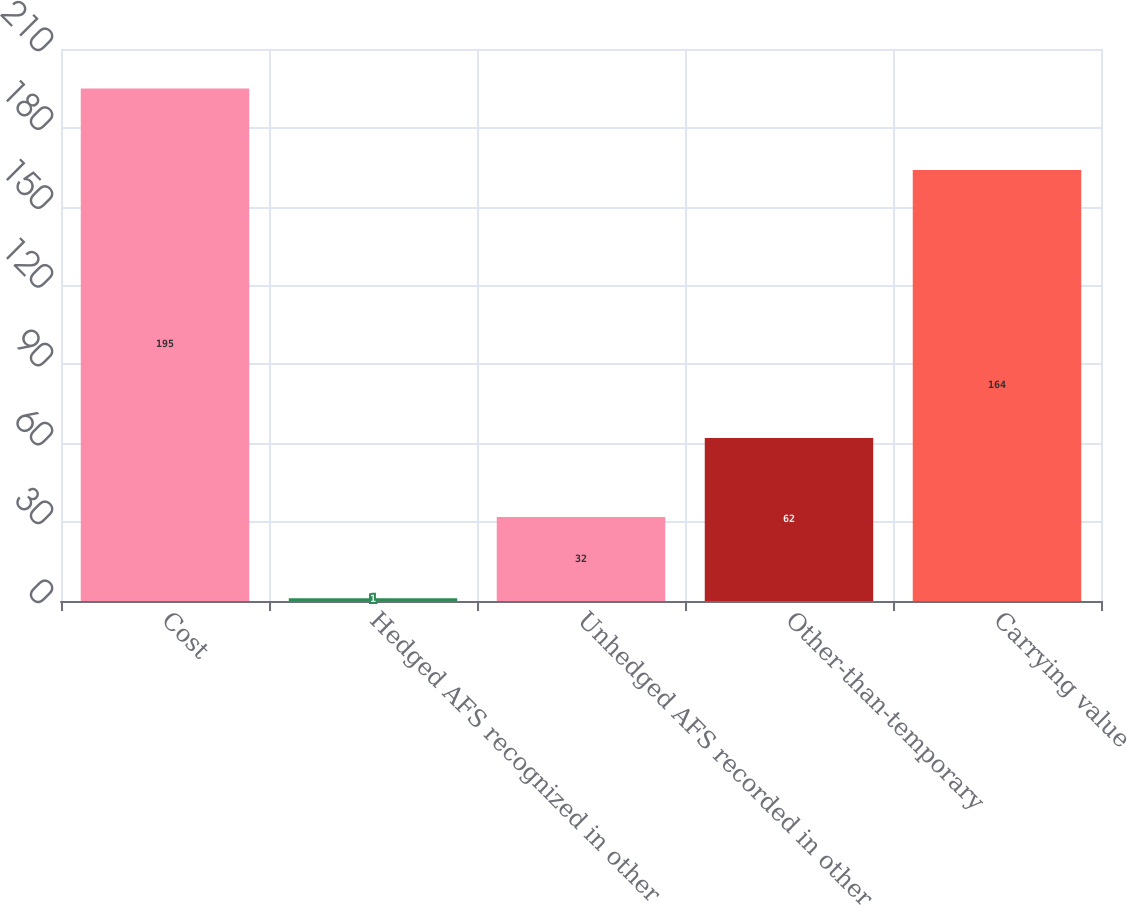Convert chart. <chart><loc_0><loc_0><loc_500><loc_500><bar_chart><fcel>Cost<fcel>Hedged AFS recognized in other<fcel>Unhedged AFS recorded in other<fcel>Other-than-temporary<fcel>Carrying value<nl><fcel>195<fcel>1<fcel>32<fcel>62<fcel>164<nl></chart> 